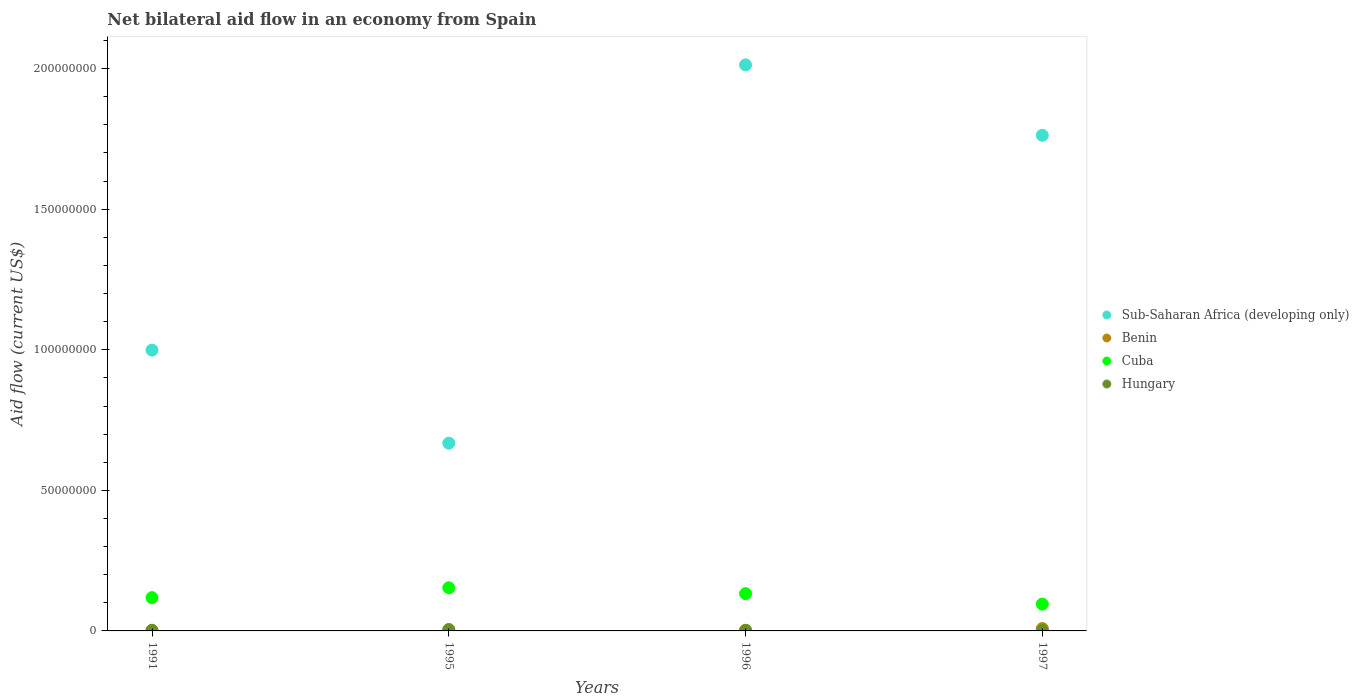How many different coloured dotlines are there?
Your answer should be compact. 4. Across all years, what is the maximum net bilateral aid flow in Cuba?
Offer a very short reply. 1.54e+07. Across all years, what is the minimum net bilateral aid flow in Hungary?
Offer a very short reply. 1.60e+05. In which year was the net bilateral aid flow in Cuba minimum?
Offer a very short reply. 1997. What is the total net bilateral aid flow in Benin in the graph?
Offer a very short reply. 1.16e+06. What is the difference between the net bilateral aid flow in Hungary in 1995 and that in 1997?
Make the answer very short. 3.50e+05. What is the difference between the net bilateral aid flow in Cuba in 1991 and the net bilateral aid flow in Hungary in 1997?
Provide a succinct answer. 1.17e+07. In the year 1996, what is the difference between the net bilateral aid flow in Cuba and net bilateral aid flow in Sub-Saharan Africa (developing only)?
Your answer should be compact. -1.88e+08. In how many years, is the net bilateral aid flow in Hungary greater than 120000000 US$?
Offer a terse response. 0. What is the ratio of the net bilateral aid flow in Hungary in 1995 to that in 1996?
Provide a succinct answer. 2.32. Is the net bilateral aid flow in Hungary in 1991 less than that in 1995?
Offer a very short reply. Yes. Is the difference between the net bilateral aid flow in Cuba in 1995 and 1997 greater than the difference between the net bilateral aid flow in Sub-Saharan Africa (developing only) in 1995 and 1997?
Offer a very short reply. Yes. What is the difference between the highest and the second highest net bilateral aid flow in Sub-Saharan Africa (developing only)?
Your response must be concise. 2.50e+07. What is the difference between the highest and the lowest net bilateral aid flow in Cuba?
Your answer should be very brief. 5.80e+06. In how many years, is the net bilateral aid flow in Cuba greater than the average net bilateral aid flow in Cuba taken over all years?
Your answer should be very brief. 2. Is the sum of the net bilateral aid flow in Benin in 1991 and 1995 greater than the maximum net bilateral aid flow in Sub-Saharan Africa (developing only) across all years?
Offer a very short reply. No. Is it the case that in every year, the sum of the net bilateral aid flow in Benin and net bilateral aid flow in Sub-Saharan Africa (developing only)  is greater than the sum of net bilateral aid flow in Cuba and net bilateral aid flow in Hungary?
Your answer should be compact. No. Does the net bilateral aid flow in Sub-Saharan Africa (developing only) monotonically increase over the years?
Your answer should be very brief. No. Is the net bilateral aid flow in Sub-Saharan Africa (developing only) strictly less than the net bilateral aid flow in Cuba over the years?
Keep it short and to the point. No. Does the graph contain any zero values?
Keep it short and to the point. No. How many legend labels are there?
Your answer should be very brief. 4. What is the title of the graph?
Make the answer very short. Net bilateral aid flow in an economy from Spain. Does "Lithuania" appear as one of the legend labels in the graph?
Ensure brevity in your answer.  No. What is the label or title of the X-axis?
Keep it short and to the point. Years. What is the Aid flow (current US$) in Sub-Saharan Africa (developing only) in 1991?
Make the answer very short. 9.99e+07. What is the Aid flow (current US$) in Cuba in 1991?
Offer a terse response. 1.18e+07. What is the Aid flow (current US$) in Hungary in 1991?
Keep it short and to the point. 2.40e+05. What is the Aid flow (current US$) of Sub-Saharan Africa (developing only) in 1995?
Offer a very short reply. 6.68e+07. What is the Aid flow (current US$) of Cuba in 1995?
Make the answer very short. 1.54e+07. What is the Aid flow (current US$) of Hungary in 1995?
Your response must be concise. 5.10e+05. What is the Aid flow (current US$) in Sub-Saharan Africa (developing only) in 1996?
Make the answer very short. 2.01e+08. What is the Aid flow (current US$) of Cuba in 1996?
Give a very brief answer. 1.32e+07. What is the Aid flow (current US$) in Sub-Saharan Africa (developing only) in 1997?
Keep it short and to the point. 1.76e+08. What is the Aid flow (current US$) in Benin in 1997?
Your answer should be compact. 8.40e+05. What is the Aid flow (current US$) in Cuba in 1997?
Your response must be concise. 9.55e+06. Across all years, what is the maximum Aid flow (current US$) of Sub-Saharan Africa (developing only)?
Ensure brevity in your answer.  2.01e+08. Across all years, what is the maximum Aid flow (current US$) in Benin?
Your answer should be compact. 8.40e+05. Across all years, what is the maximum Aid flow (current US$) of Cuba?
Ensure brevity in your answer.  1.54e+07. Across all years, what is the maximum Aid flow (current US$) in Hungary?
Ensure brevity in your answer.  5.10e+05. Across all years, what is the minimum Aid flow (current US$) in Sub-Saharan Africa (developing only)?
Provide a short and direct response. 6.68e+07. Across all years, what is the minimum Aid flow (current US$) in Cuba?
Offer a very short reply. 9.55e+06. What is the total Aid flow (current US$) of Sub-Saharan Africa (developing only) in the graph?
Make the answer very short. 5.44e+08. What is the total Aid flow (current US$) of Benin in the graph?
Offer a very short reply. 1.16e+06. What is the total Aid flow (current US$) of Cuba in the graph?
Make the answer very short. 5.00e+07. What is the total Aid flow (current US$) in Hungary in the graph?
Your answer should be very brief. 1.13e+06. What is the difference between the Aid flow (current US$) of Sub-Saharan Africa (developing only) in 1991 and that in 1995?
Your answer should be compact. 3.31e+07. What is the difference between the Aid flow (current US$) of Cuba in 1991 and that in 1995?
Ensure brevity in your answer.  -3.51e+06. What is the difference between the Aid flow (current US$) in Hungary in 1991 and that in 1995?
Offer a very short reply. -2.70e+05. What is the difference between the Aid flow (current US$) of Sub-Saharan Africa (developing only) in 1991 and that in 1996?
Provide a succinct answer. -1.01e+08. What is the difference between the Aid flow (current US$) of Benin in 1991 and that in 1996?
Keep it short and to the point. -1.70e+05. What is the difference between the Aid flow (current US$) of Cuba in 1991 and that in 1996?
Your answer should be very brief. -1.41e+06. What is the difference between the Aid flow (current US$) in Sub-Saharan Africa (developing only) in 1991 and that in 1997?
Your answer should be very brief. -7.64e+07. What is the difference between the Aid flow (current US$) of Benin in 1991 and that in 1997?
Provide a short and direct response. -8.10e+05. What is the difference between the Aid flow (current US$) in Cuba in 1991 and that in 1997?
Offer a very short reply. 2.29e+06. What is the difference between the Aid flow (current US$) of Hungary in 1991 and that in 1997?
Provide a short and direct response. 8.00e+04. What is the difference between the Aid flow (current US$) of Sub-Saharan Africa (developing only) in 1995 and that in 1996?
Offer a terse response. -1.35e+08. What is the difference between the Aid flow (current US$) in Cuba in 1995 and that in 1996?
Your answer should be very brief. 2.10e+06. What is the difference between the Aid flow (current US$) of Sub-Saharan Africa (developing only) in 1995 and that in 1997?
Keep it short and to the point. -1.10e+08. What is the difference between the Aid flow (current US$) of Benin in 1995 and that in 1997?
Offer a very short reply. -7.50e+05. What is the difference between the Aid flow (current US$) in Cuba in 1995 and that in 1997?
Your answer should be compact. 5.80e+06. What is the difference between the Aid flow (current US$) of Sub-Saharan Africa (developing only) in 1996 and that in 1997?
Your answer should be compact. 2.50e+07. What is the difference between the Aid flow (current US$) of Benin in 1996 and that in 1997?
Give a very brief answer. -6.40e+05. What is the difference between the Aid flow (current US$) of Cuba in 1996 and that in 1997?
Give a very brief answer. 3.70e+06. What is the difference between the Aid flow (current US$) in Hungary in 1996 and that in 1997?
Provide a succinct answer. 6.00e+04. What is the difference between the Aid flow (current US$) in Sub-Saharan Africa (developing only) in 1991 and the Aid flow (current US$) in Benin in 1995?
Offer a very short reply. 9.98e+07. What is the difference between the Aid flow (current US$) in Sub-Saharan Africa (developing only) in 1991 and the Aid flow (current US$) in Cuba in 1995?
Your answer should be very brief. 8.45e+07. What is the difference between the Aid flow (current US$) of Sub-Saharan Africa (developing only) in 1991 and the Aid flow (current US$) of Hungary in 1995?
Give a very brief answer. 9.94e+07. What is the difference between the Aid flow (current US$) in Benin in 1991 and the Aid flow (current US$) in Cuba in 1995?
Keep it short and to the point. -1.53e+07. What is the difference between the Aid flow (current US$) of Benin in 1991 and the Aid flow (current US$) of Hungary in 1995?
Offer a very short reply. -4.80e+05. What is the difference between the Aid flow (current US$) in Cuba in 1991 and the Aid flow (current US$) in Hungary in 1995?
Make the answer very short. 1.13e+07. What is the difference between the Aid flow (current US$) in Sub-Saharan Africa (developing only) in 1991 and the Aid flow (current US$) in Benin in 1996?
Your answer should be compact. 9.97e+07. What is the difference between the Aid flow (current US$) in Sub-Saharan Africa (developing only) in 1991 and the Aid flow (current US$) in Cuba in 1996?
Provide a succinct answer. 8.66e+07. What is the difference between the Aid flow (current US$) in Sub-Saharan Africa (developing only) in 1991 and the Aid flow (current US$) in Hungary in 1996?
Your response must be concise. 9.97e+07. What is the difference between the Aid flow (current US$) in Benin in 1991 and the Aid flow (current US$) in Cuba in 1996?
Your response must be concise. -1.32e+07. What is the difference between the Aid flow (current US$) in Benin in 1991 and the Aid flow (current US$) in Hungary in 1996?
Your response must be concise. -1.90e+05. What is the difference between the Aid flow (current US$) of Cuba in 1991 and the Aid flow (current US$) of Hungary in 1996?
Keep it short and to the point. 1.16e+07. What is the difference between the Aid flow (current US$) in Sub-Saharan Africa (developing only) in 1991 and the Aid flow (current US$) in Benin in 1997?
Offer a terse response. 9.90e+07. What is the difference between the Aid flow (current US$) of Sub-Saharan Africa (developing only) in 1991 and the Aid flow (current US$) of Cuba in 1997?
Keep it short and to the point. 9.03e+07. What is the difference between the Aid flow (current US$) of Sub-Saharan Africa (developing only) in 1991 and the Aid flow (current US$) of Hungary in 1997?
Provide a succinct answer. 9.97e+07. What is the difference between the Aid flow (current US$) in Benin in 1991 and the Aid flow (current US$) in Cuba in 1997?
Offer a terse response. -9.52e+06. What is the difference between the Aid flow (current US$) of Benin in 1991 and the Aid flow (current US$) of Hungary in 1997?
Provide a short and direct response. -1.30e+05. What is the difference between the Aid flow (current US$) of Cuba in 1991 and the Aid flow (current US$) of Hungary in 1997?
Your answer should be compact. 1.17e+07. What is the difference between the Aid flow (current US$) in Sub-Saharan Africa (developing only) in 1995 and the Aid flow (current US$) in Benin in 1996?
Keep it short and to the point. 6.66e+07. What is the difference between the Aid flow (current US$) in Sub-Saharan Africa (developing only) in 1995 and the Aid flow (current US$) in Cuba in 1996?
Ensure brevity in your answer.  5.35e+07. What is the difference between the Aid flow (current US$) in Sub-Saharan Africa (developing only) in 1995 and the Aid flow (current US$) in Hungary in 1996?
Your answer should be very brief. 6.66e+07. What is the difference between the Aid flow (current US$) in Benin in 1995 and the Aid flow (current US$) in Cuba in 1996?
Provide a short and direct response. -1.32e+07. What is the difference between the Aid flow (current US$) in Benin in 1995 and the Aid flow (current US$) in Hungary in 1996?
Make the answer very short. -1.30e+05. What is the difference between the Aid flow (current US$) of Cuba in 1995 and the Aid flow (current US$) of Hungary in 1996?
Your response must be concise. 1.51e+07. What is the difference between the Aid flow (current US$) in Sub-Saharan Africa (developing only) in 1995 and the Aid flow (current US$) in Benin in 1997?
Offer a terse response. 6.59e+07. What is the difference between the Aid flow (current US$) in Sub-Saharan Africa (developing only) in 1995 and the Aid flow (current US$) in Cuba in 1997?
Offer a very short reply. 5.72e+07. What is the difference between the Aid flow (current US$) in Sub-Saharan Africa (developing only) in 1995 and the Aid flow (current US$) in Hungary in 1997?
Ensure brevity in your answer.  6.66e+07. What is the difference between the Aid flow (current US$) in Benin in 1995 and the Aid flow (current US$) in Cuba in 1997?
Ensure brevity in your answer.  -9.46e+06. What is the difference between the Aid flow (current US$) of Benin in 1995 and the Aid flow (current US$) of Hungary in 1997?
Offer a very short reply. -7.00e+04. What is the difference between the Aid flow (current US$) of Cuba in 1995 and the Aid flow (current US$) of Hungary in 1997?
Provide a succinct answer. 1.52e+07. What is the difference between the Aid flow (current US$) of Sub-Saharan Africa (developing only) in 1996 and the Aid flow (current US$) of Benin in 1997?
Ensure brevity in your answer.  2.00e+08. What is the difference between the Aid flow (current US$) of Sub-Saharan Africa (developing only) in 1996 and the Aid flow (current US$) of Cuba in 1997?
Your answer should be compact. 1.92e+08. What is the difference between the Aid flow (current US$) of Sub-Saharan Africa (developing only) in 1996 and the Aid flow (current US$) of Hungary in 1997?
Give a very brief answer. 2.01e+08. What is the difference between the Aid flow (current US$) of Benin in 1996 and the Aid flow (current US$) of Cuba in 1997?
Your answer should be compact. -9.35e+06. What is the difference between the Aid flow (current US$) in Cuba in 1996 and the Aid flow (current US$) in Hungary in 1997?
Ensure brevity in your answer.  1.31e+07. What is the average Aid flow (current US$) of Sub-Saharan Africa (developing only) per year?
Your answer should be very brief. 1.36e+08. What is the average Aid flow (current US$) of Benin per year?
Keep it short and to the point. 2.90e+05. What is the average Aid flow (current US$) of Cuba per year?
Keep it short and to the point. 1.25e+07. What is the average Aid flow (current US$) in Hungary per year?
Your answer should be very brief. 2.82e+05. In the year 1991, what is the difference between the Aid flow (current US$) in Sub-Saharan Africa (developing only) and Aid flow (current US$) in Benin?
Ensure brevity in your answer.  9.99e+07. In the year 1991, what is the difference between the Aid flow (current US$) of Sub-Saharan Africa (developing only) and Aid flow (current US$) of Cuba?
Keep it short and to the point. 8.80e+07. In the year 1991, what is the difference between the Aid flow (current US$) of Sub-Saharan Africa (developing only) and Aid flow (current US$) of Hungary?
Keep it short and to the point. 9.96e+07. In the year 1991, what is the difference between the Aid flow (current US$) in Benin and Aid flow (current US$) in Cuba?
Provide a succinct answer. -1.18e+07. In the year 1991, what is the difference between the Aid flow (current US$) of Cuba and Aid flow (current US$) of Hungary?
Your answer should be compact. 1.16e+07. In the year 1995, what is the difference between the Aid flow (current US$) of Sub-Saharan Africa (developing only) and Aid flow (current US$) of Benin?
Offer a very short reply. 6.67e+07. In the year 1995, what is the difference between the Aid flow (current US$) in Sub-Saharan Africa (developing only) and Aid flow (current US$) in Cuba?
Provide a succinct answer. 5.14e+07. In the year 1995, what is the difference between the Aid flow (current US$) in Sub-Saharan Africa (developing only) and Aid flow (current US$) in Hungary?
Ensure brevity in your answer.  6.63e+07. In the year 1995, what is the difference between the Aid flow (current US$) in Benin and Aid flow (current US$) in Cuba?
Provide a short and direct response. -1.53e+07. In the year 1995, what is the difference between the Aid flow (current US$) of Benin and Aid flow (current US$) of Hungary?
Keep it short and to the point. -4.20e+05. In the year 1995, what is the difference between the Aid flow (current US$) in Cuba and Aid flow (current US$) in Hungary?
Ensure brevity in your answer.  1.48e+07. In the year 1996, what is the difference between the Aid flow (current US$) in Sub-Saharan Africa (developing only) and Aid flow (current US$) in Benin?
Ensure brevity in your answer.  2.01e+08. In the year 1996, what is the difference between the Aid flow (current US$) of Sub-Saharan Africa (developing only) and Aid flow (current US$) of Cuba?
Your answer should be compact. 1.88e+08. In the year 1996, what is the difference between the Aid flow (current US$) in Sub-Saharan Africa (developing only) and Aid flow (current US$) in Hungary?
Your answer should be compact. 2.01e+08. In the year 1996, what is the difference between the Aid flow (current US$) in Benin and Aid flow (current US$) in Cuba?
Offer a terse response. -1.30e+07. In the year 1996, what is the difference between the Aid flow (current US$) in Cuba and Aid flow (current US$) in Hungary?
Ensure brevity in your answer.  1.30e+07. In the year 1997, what is the difference between the Aid flow (current US$) of Sub-Saharan Africa (developing only) and Aid flow (current US$) of Benin?
Your answer should be very brief. 1.75e+08. In the year 1997, what is the difference between the Aid flow (current US$) in Sub-Saharan Africa (developing only) and Aid flow (current US$) in Cuba?
Make the answer very short. 1.67e+08. In the year 1997, what is the difference between the Aid flow (current US$) of Sub-Saharan Africa (developing only) and Aid flow (current US$) of Hungary?
Offer a very short reply. 1.76e+08. In the year 1997, what is the difference between the Aid flow (current US$) in Benin and Aid flow (current US$) in Cuba?
Give a very brief answer. -8.71e+06. In the year 1997, what is the difference between the Aid flow (current US$) of Benin and Aid flow (current US$) of Hungary?
Your answer should be very brief. 6.80e+05. In the year 1997, what is the difference between the Aid flow (current US$) in Cuba and Aid flow (current US$) in Hungary?
Your answer should be compact. 9.39e+06. What is the ratio of the Aid flow (current US$) of Sub-Saharan Africa (developing only) in 1991 to that in 1995?
Provide a succinct answer. 1.5. What is the ratio of the Aid flow (current US$) of Benin in 1991 to that in 1995?
Provide a short and direct response. 0.33. What is the ratio of the Aid flow (current US$) of Cuba in 1991 to that in 1995?
Make the answer very short. 0.77. What is the ratio of the Aid flow (current US$) of Hungary in 1991 to that in 1995?
Keep it short and to the point. 0.47. What is the ratio of the Aid flow (current US$) of Sub-Saharan Africa (developing only) in 1991 to that in 1996?
Your answer should be very brief. 0.5. What is the ratio of the Aid flow (current US$) of Cuba in 1991 to that in 1996?
Your answer should be compact. 0.89. What is the ratio of the Aid flow (current US$) of Hungary in 1991 to that in 1996?
Your response must be concise. 1.09. What is the ratio of the Aid flow (current US$) in Sub-Saharan Africa (developing only) in 1991 to that in 1997?
Your answer should be compact. 0.57. What is the ratio of the Aid flow (current US$) of Benin in 1991 to that in 1997?
Your answer should be compact. 0.04. What is the ratio of the Aid flow (current US$) of Cuba in 1991 to that in 1997?
Make the answer very short. 1.24. What is the ratio of the Aid flow (current US$) of Hungary in 1991 to that in 1997?
Make the answer very short. 1.5. What is the ratio of the Aid flow (current US$) in Sub-Saharan Africa (developing only) in 1995 to that in 1996?
Offer a very short reply. 0.33. What is the ratio of the Aid flow (current US$) of Benin in 1995 to that in 1996?
Provide a short and direct response. 0.45. What is the ratio of the Aid flow (current US$) in Cuba in 1995 to that in 1996?
Provide a succinct answer. 1.16. What is the ratio of the Aid flow (current US$) in Hungary in 1995 to that in 1996?
Give a very brief answer. 2.32. What is the ratio of the Aid flow (current US$) in Sub-Saharan Africa (developing only) in 1995 to that in 1997?
Give a very brief answer. 0.38. What is the ratio of the Aid flow (current US$) in Benin in 1995 to that in 1997?
Make the answer very short. 0.11. What is the ratio of the Aid flow (current US$) in Cuba in 1995 to that in 1997?
Offer a terse response. 1.61. What is the ratio of the Aid flow (current US$) in Hungary in 1995 to that in 1997?
Give a very brief answer. 3.19. What is the ratio of the Aid flow (current US$) of Sub-Saharan Africa (developing only) in 1996 to that in 1997?
Ensure brevity in your answer.  1.14. What is the ratio of the Aid flow (current US$) in Benin in 1996 to that in 1997?
Provide a short and direct response. 0.24. What is the ratio of the Aid flow (current US$) of Cuba in 1996 to that in 1997?
Your answer should be very brief. 1.39. What is the ratio of the Aid flow (current US$) in Hungary in 1996 to that in 1997?
Keep it short and to the point. 1.38. What is the difference between the highest and the second highest Aid flow (current US$) in Sub-Saharan Africa (developing only)?
Provide a succinct answer. 2.50e+07. What is the difference between the highest and the second highest Aid flow (current US$) in Benin?
Make the answer very short. 6.40e+05. What is the difference between the highest and the second highest Aid flow (current US$) in Cuba?
Provide a succinct answer. 2.10e+06. What is the difference between the highest and the lowest Aid flow (current US$) of Sub-Saharan Africa (developing only)?
Offer a terse response. 1.35e+08. What is the difference between the highest and the lowest Aid flow (current US$) in Benin?
Offer a terse response. 8.10e+05. What is the difference between the highest and the lowest Aid flow (current US$) of Cuba?
Make the answer very short. 5.80e+06. What is the difference between the highest and the lowest Aid flow (current US$) in Hungary?
Offer a very short reply. 3.50e+05. 